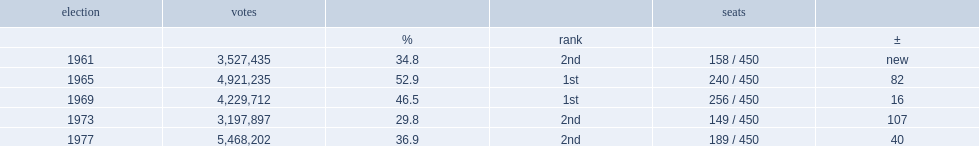In the 1961 elections,how many percent of votes went to the justice party? 34.8. 